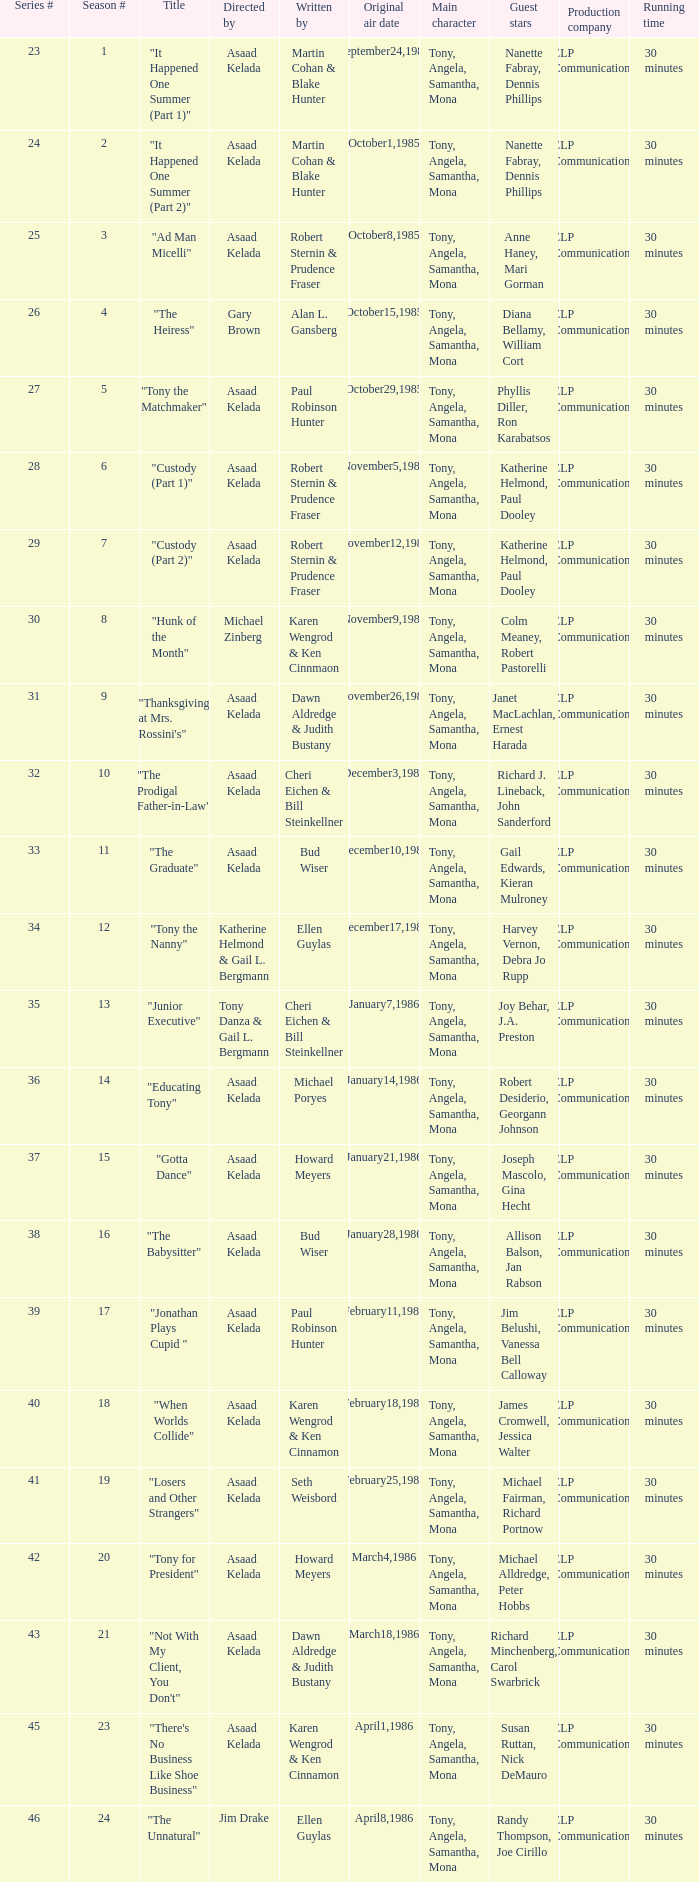What is the season where the episode "when worlds collide" was shown? 18.0. 